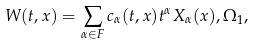Convert formula to latex. <formula><loc_0><loc_0><loc_500><loc_500>W ( t , x ) = \sum _ { \alpha \in F } c _ { \alpha } ( t , x ) t ^ { \alpha } X _ { \alpha } ( x ) , \Omega _ { 1 } ,</formula> 